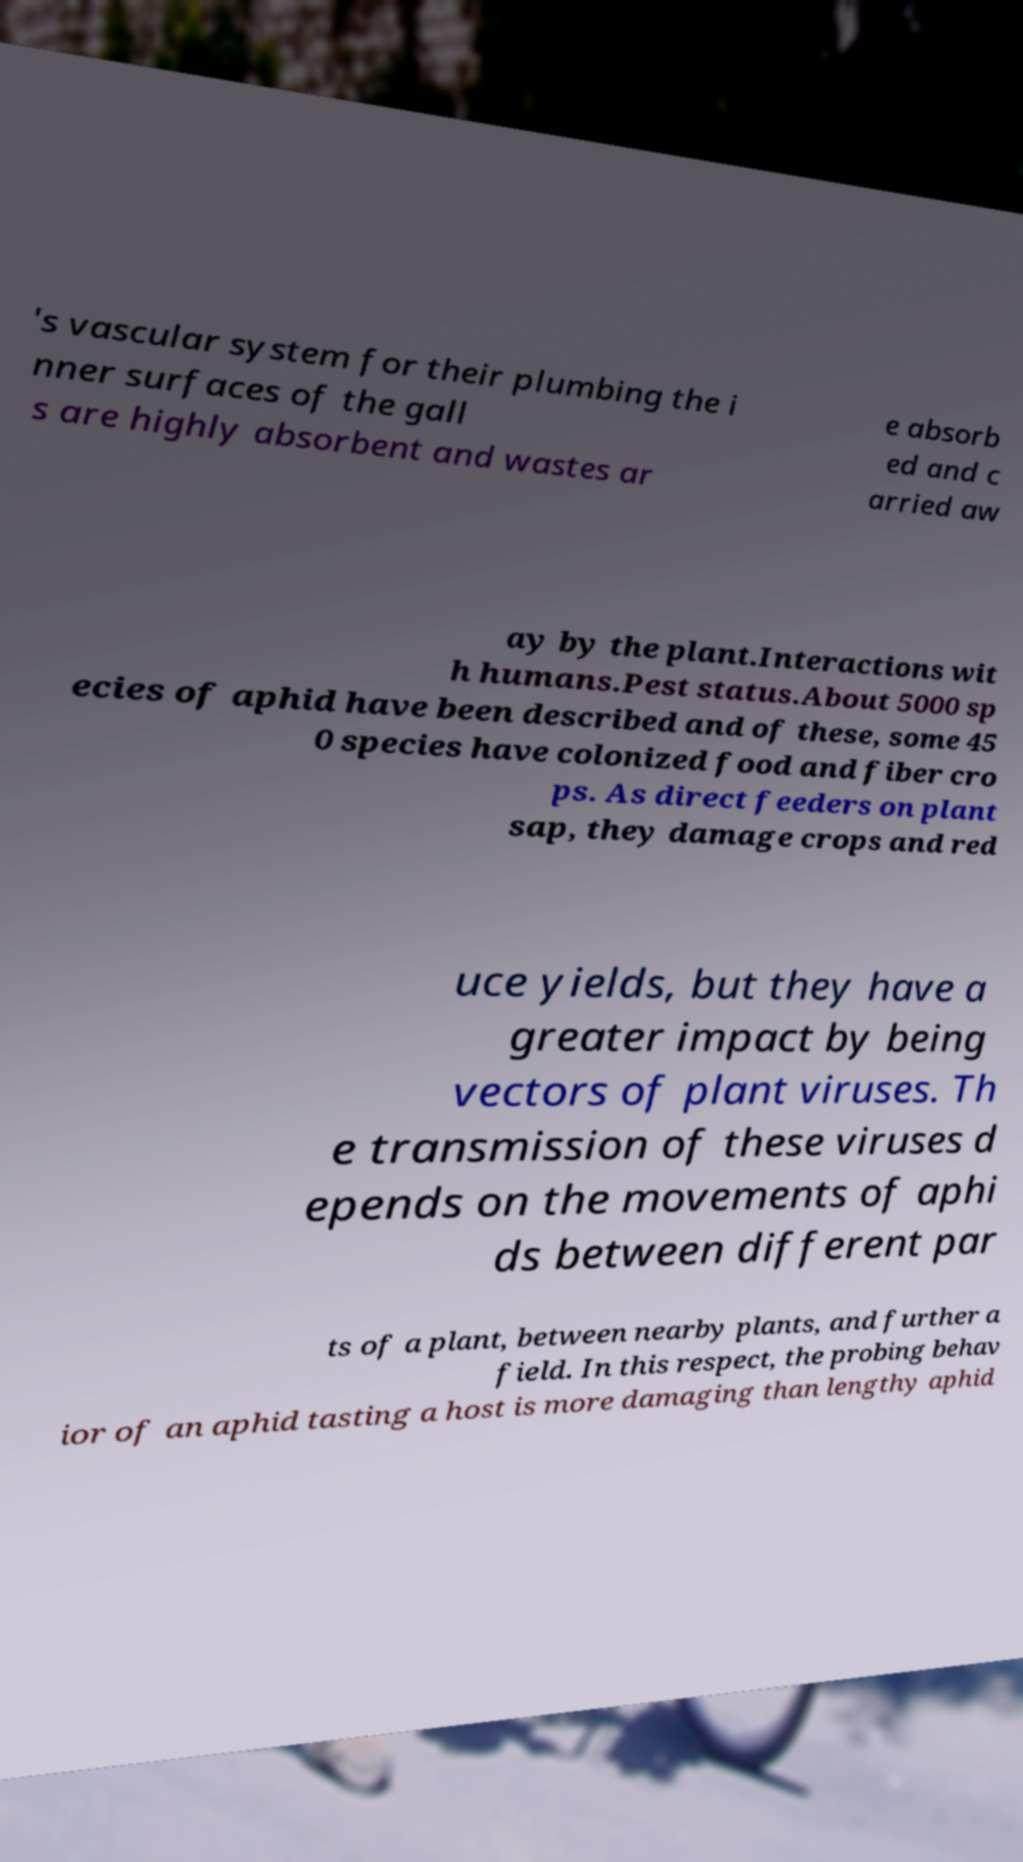Could you assist in decoding the text presented in this image and type it out clearly? 's vascular system for their plumbing the i nner surfaces of the gall s are highly absorbent and wastes ar e absorb ed and c arried aw ay by the plant.Interactions wit h humans.Pest status.About 5000 sp ecies of aphid have been described and of these, some 45 0 species have colonized food and fiber cro ps. As direct feeders on plant sap, they damage crops and red uce yields, but they have a greater impact by being vectors of plant viruses. Th e transmission of these viruses d epends on the movements of aphi ds between different par ts of a plant, between nearby plants, and further a field. In this respect, the probing behav ior of an aphid tasting a host is more damaging than lengthy aphid 